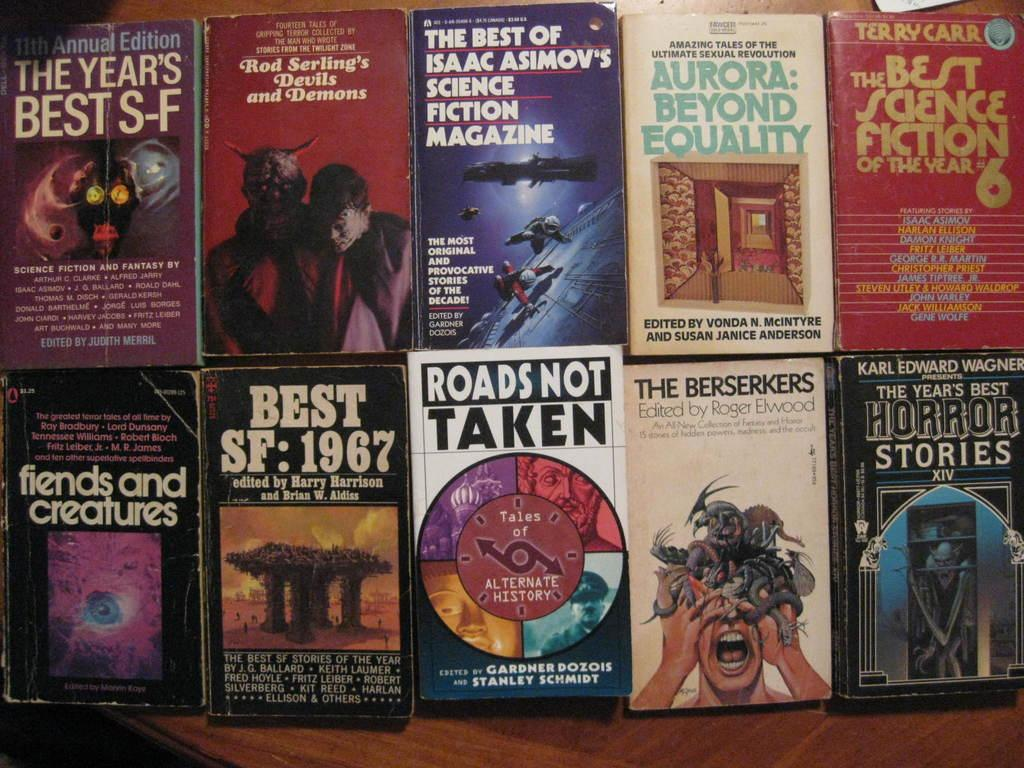<image>
Write a terse but informative summary of the picture. Several old science fiction books including titles such as ROADS NOT TAKEN and fiends and creatures. 